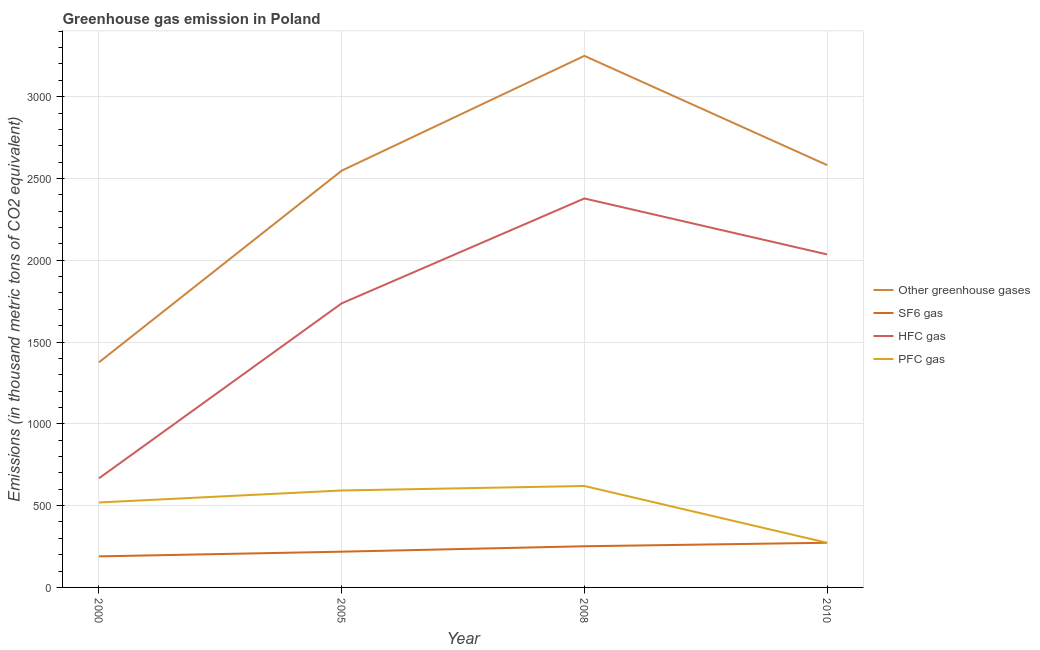Is the number of lines equal to the number of legend labels?
Make the answer very short. Yes. What is the emission of hfc gas in 2000?
Your answer should be compact. 667.2. Across all years, what is the maximum emission of pfc gas?
Provide a short and direct response. 620.1. Across all years, what is the minimum emission of greenhouse gases?
Your answer should be very brief. 1376.3. In which year was the emission of pfc gas maximum?
Offer a terse response. 2008. What is the total emission of sf6 gas in the graph?
Your answer should be compact. 933. What is the difference between the emission of hfc gas in 2005 and that in 2010?
Provide a succinct answer. -299.3. What is the difference between the emission of pfc gas in 2000 and the emission of greenhouse gases in 2008?
Make the answer very short. -2730.5. What is the average emission of sf6 gas per year?
Your response must be concise. 233.25. In the year 2005, what is the difference between the emission of pfc gas and emission of hfc gas?
Your answer should be very brief. -1144. What is the ratio of the emission of hfc gas in 2000 to that in 2008?
Your response must be concise. 0.28. Is the emission of pfc gas in 2000 less than that in 2008?
Provide a short and direct response. Yes. Is the difference between the emission of hfc gas in 2005 and 2010 greater than the difference between the emission of greenhouse gases in 2005 and 2010?
Keep it short and to the point. No. What is the difference between the highest and the second highest emission of sf6 gas?
Give a very brief answer. 21.3. What is the difference between the highest and the lowest emission of sf6 gas?
Provide a succinct answer. 83.2. In how many years, is the emission of hfc gas greater than the average emission of hfc gas taken over all years?
Make the answer very short. 3. Is it the case that in every year, the sum of the emission of sf6 gas and emission of greenhouse gases is greater than the sum of emission of hfc gas and emission of pfc gas?
Offer a terse response. No. Is it the case that in every year, the sum of the emission of greenhouse gases and emission of sf6 gas is greater than the emission of hfc gas?
Give a very brief answer. Yes. Does the emission of pfc gas monotonically increase over the years?
Your response must be concise. No. Is the emission of hfc gas strictly less than the emission of pfc gas over the years?
Give a very brief answer. No. How many lines are there?
Make the answer very short. 4. How many years are there in the graph?
Provide a short and direct response. 4. Does the graph contain any zero values?
Keep it short and to the point. No. How many legend labels are there?
Make the answer very short. 4. What is the title of the graph?
Provide a succinct answer. Greenhouse gas emission in Poland. What is the label or title of the X-axis?
Your answer should be very brief. Year. What is the label or title of the Y-axis?
Offer a very short reply. Emissions (in thousand metric tons of CO2 equivalent). What is the Emissions (in thousand metric tons of CO2 equivalent) in Other greenhouse gases in 2000?
Your answer should be very brief. 1376.3. What is the Emissions (in thousand metric tons of CO2 equivalent) of SF6 gas in 2000?
Your answer should be compact. 189.8. What is the Emissions (in thousand metric tons of CO2 equivalent) in HFC gas in 2000?
Your answer should be compact. 667.2. What is the Emissions (in thousand metric tons of CO2 equivalent) in PFC gas in 2000?
Provide a short and direct response. 519.3. What is the Emissions (in thousand metric tons of CO2 equivalent) in Other greenhouse gases in 2005?
Provide a short and direct response. 2547.9. What is the Emissions (in thousand metric tons of CO2 equivalent) of SF6 gas in 2005?
Offer a terse response. 218.5. What is the Emissions (in thousand metric tons of CO2 equivalent) of HFC gas in 2005?
Provide a succinct answer. 1736.7. What is the Emissions (in thousand metric tons of CO2 equivalent) in PFC gas in 2005?
Your answer should be very brief. 592.7. What is the Emissions (in thousand metric tons of CO2 equivalent) of Other greenhouse gases in 2008?
Provide a succinct answer. 3249.8. What is the Emissions (in thousand metric tons of CO2 equivalent) of SF6 gas in 2008?
Offer a very short reply. 251.7. What is the Emissions (in thousand metric tons of CO2 equivalent) of HFC gas in 2008?
Give a very brief answer. 2378. What is the Emissions (in thousand metric tons of CO2 equivalent) in PFC gas in 2008?
Your response must be concise. 620.1. What is the Emissions (in thousand metric tons of CO2 equivalent) in Other greenhouse gases in 2010?
Keep it short and to the point. 2582. What is the Emissions (in thousand metric tons of CO2 equivalent) of SF6 gas in 2010?
Provide a short and direct response. 273. What is the Emissions (in thousand metric tons of CO2 equivalent) of HFC gas in 2010?
Your response must be concise. 2036. What is the Emissions (in thousand metric tons of CO2 equivalent) in PFC gas in 2010?
Your answer should be very brief. 273. Across all years, what is the maximum Emissions (in thousand metric tons of CO2 equivalent) in Other greenhouse gases?
Offer a terse response. 3249.8. Across all years, what is the maximum Emissions (in thousand metric tons of CO2 equivalent) of SF6 gas?
Provide a short and direct response. 273. Across all years, what is the maximum Emissions (in thousand metric tons of CO2 equivalent) of HFC gas?
Provide a short and direct response. 2378. Across all years, what is the maximum Emissions (in thousand metric tons of CO2 equivalent) in PFC gas?
Your response must be concise. 620.1. Across all years, what is the minimum Emissions (in thousand metric tons of CO2 equivalent) of Other greenhouse gases?
Ensure brevity in your answer.  1376.3. Across all years, what is the minimum Emissions (in thousand metric tons of CO2 equivalent) of SF6 gas?
Your answer should be very brief. 189.8. Across all years, what is the minimum Emissions (in thousand metric tons of CO2 equivalent) in HFC gas?
Your answer should be very brief. 667.2. Across all years, what is the minimum Emissions (in thousand metric tons of CO2 equivalent) of PFC gas?
Offer a terse response. 273. What is the total Emissions (in thousand metric tons of CO2 equivalent) in Other greenhouse gases in the graph?
Give a very brief answer. 9756. What is the total Emissions (in thousand metric tons of CO2 equivalent) of SF6 gas in the graph?
Your answer should be very brief. 933. What is the total Emissions (in thousand metric tons of CO2 equivalent) of HFC gas in the graph?
Provide a succinct answer. 6817.9. What is the total Emissions (in thousand metric tons of CO2 equivalent) of PFC gas in the graph?
Ensure brevity in your answer.  2005.1. What is the difference between the Emissions (in thousand metric tons of CO2 equivalent) in Other greenhouse gases in 2000 and that in 2005?
Your answer should be very brief. -1171.6. What is the difference between the Emissions (in thousand metric tons of CO2 equivalent) of SF6 gas in 2000 and that in 2005?
Your answer should be very brief. -28.7. What is the difference between the Emissions (in thousand metric tons of CO2 equivalent) of HFC gas in 2000 and that in 2005?
Provide a short and direct response. -1069.5. What is the difference between the Emissions (in thousand metric tons of CO2 equivalent) of PFC gas in 2000 and that in 2005?
Your answer should be very brief. -73.4. What is the difference between the Emissions (in thousand metric tons of CO2 equivalent) of Other greenhouse gases in 2000 and that in 2008?
Make the answer very short. -1873.5. What is the difference between the Emissions (in thousand metric tons of CO2 equivalent) of SF6 gas in 2000 and that in 2008?
Provide a succinct answer. -61.9. What is the difference between the Emissions (in thousand metric tons of CO2 equivalent) in HFC gas in 2000 and that in 2008?
Your response must be concise. -1710.8. What is the difference between the Emissions (in thousand metric tons of CO2 equivalent) in PFC gas in 2000 and that in 2008?
Provide a succinct answer. -100.8. What is the difference between the Emissions (in thousand metric tons of CO2 equivalent) in Other greenhouse gases in 2000 and that in 2010?
Offer a terse response. -1205.7. What is the difference between the Emissions (in thousand metric tons of CO2 equivalent) of SF6 gas in 2000 and that in 2010?
Ensure brevity in your answer.  -83.2. What is the difference between the Emissions (in thousand metric tons of CO2 equivalent) in HFC gas in 2000 and that in 2010?
Keep it short and to the point. -1368.8. What is the difference between the Emissions (in thousand metric tons of CO2 equivalent) of PFC gas in 2000 and that in 2010?
Make the answer very short. 246.3. What is the difference between the Emissions (in thousand metric tons of CO2 equivalent) of Other greenhouse gases in 2005 and that in 2008?
Offer a terse response. -701.9. What is the difference between the Emissions (in thousand metric tons of CO2 equivalent) in SF6 gas in 2005 and that in 2008?
Provide a short and direct response. -33.2. What is the difference between the Emissions (in thousand metric tons of CO2 equivalent) in HFC gas in 2005 and that in 2008?
Give a very brief answer. -641.3. What is the difference between the Emissions (in thousand metric tons of CO2 equivalent) of PFC gas in 2005 and that in 2008?
Give a very brief answer. -27.4. What is the difference between the Emissions (in thousand metric tons of CO2 equivalent) in Other greenhouse gases in 2005 and that in 2010?
Offer a terse response. -34.1. What is the difference between the Emissions (in thousand metric tons of CO2 equivalent) of SF6 gas in 2005 and that in 2010?
Offer a very short reply. -54.5. What is the difference between the Emissions (in thousand metric tons of CO2 equivalent) of HFC gas in 2005 and that in 2010?
Keep it short and to the point. -299.3. What is the difference between the Emissions (in thousand metric tons of CO2 equivalent) of PFC gas in 2005 and that in 2010?
Ensure brevity in your answer.  319.7. What is the difference between the Emissions (in thousand metric tons of CO2 equivalent) of Other greenhouse gases in 2008 and that in 2010?
Provide a short and direct response. 667.8. What is the difference between the Emissions (in thousand metric tons of CO2 equivalent) in SF6 gas in 2008 and that in 2010?
Your answer should be compact. -21.3. What is the difference between the Emissions (in thousand metric tons of CO2 equivalent) of HFC gas in 2008 and that in 2010?
Provide a short and direct response. 342. What is the difference between the Emissions (in thousand metric tons of CO2 equivalent) in PFC gas in 2008 and that in 2010?
Offer a terse response. 347.1. What is the difference between the Emissions (in thousand metric tons of CO2 equivalent) in Other greenhouse gases in 2000 and the Emissions (in thousand metric tons of CO2 equivalent) in SF6 gas in 2005?
Keep it short and to the point. 1157.8. What is the difference between the Emissions (in thousand metric tons of CO2 equivalent) of Other greenhouse gases in 2000 and the Emissions (in thousand metric tons of CO2 equivalent) of HFC gas in 2005?
Provide a succinct answer. -360.4. What is the difference between the Emissions (in thousand metric tons of CO2 equivalent) of Other greenhouse gases in 2000 and the Emissions (in thousand metric tons of CO2 equivalent) of PFC gas in 2005?
Offer a very short reply. 783.6. What is the difference between the Emissions (in thousand metric tons of CO2 equivalent) in SF6 gas in 2000 and the Emissions (in thousand metric tons of CO2 equivalent) in HFC gas in 2005?
Your answer should be very brief. -1546.9. What is the difference between the Emissions (in thousand metric tons of CO2 equivalent) in SF6 gas in 2000 and the Emissions (in thousand metric tons of CO2 equivalent) in PFC gas in 2005?
Ensure brevity in your answer.  -402.9. What is the difference between the Emissions (in thousand metric tons of CO2 equivalent) of HFC gas in 2000 and the Emissions (in thousand metric tons of CO2 equivalent) of PFC gas in 2005?
Ensure brevity in your answer.  74.5. What is the difference between the Emissions (in thousand metric tons of CO2 equivalent) in Other greenhouse gases in 2000 and the Emissions (in thousand metric tons of CO2 equivalent) in SF6 gas in 2008?
Offer a very short reply. 1124.6. What is the difference between the Emissions (in thousand metric tons of CO2 equivalent) of Other greenhouse gases in 2000 and the Emissions (in thousand metric tons of CO2 equivalent) of HFC gas in 2008?
Keep it short and to the point. -1001.7. What is the difference between the Emissions (in thousand metric tons of CO2 equivalent) in Other greenhouse gases in 2000 and the Emissions (in thousand metric tons of CO2 equivalent) in PFC gas in 2008?
Offer a very short reply. 756.2. What is the difference between the Emissions (in thousand metric tons of CO2 equivalent) in SF6 gas in 2000 and the Emissions (in thousand metric tons of CO2 equivalent) in HFC gas in 2008?
Provide a succinct answer. -2188.2. What is the difference between the Emissions (in thousand metric tons of CO2 equivalent) in SF6 gas in 2000 and the Emissions (in thousand metric tons of CO2 equivalent) in PFC gas in 2008?
Your response must be concise. -430.3. What is the difference between the Emissions (in thousand metric tons of CO2 equivalent) in HFC gas in 2000 and the Emissions (in thousand metric tons of CO2 equivalent) in PFC gas in 2008?
Provide a succinct answer. 47.1. What is the difference between the Emissions (in thousand metric tons of CO2 equivalent) of Other greenhouse gases in 2000 and the Emissions (in thousand metric tons of CO2 equivalent) of SF6 gas in 2010?
Offer a terse response. 1103.3. What is the difference between the Emissions (in thousand metric tons of CO2 equivalent) in Other greenhouse gases in 2000 and the Emissions (in thousand metric tons of CO2 equivalent) in HFC gas in 2010?
Offer a terse response. -659.7. What is the difference between the Emissions (in thousand metric tons of CO2 equivalent) in Other greenhouse gases in 2000 and the Emissions (in thousand metric tons of CO2 equivalent) in PFC gas in 2010?
Provide a succinct answer. 1103.3. What is the difference between the Emissions (in thousand metric tons of CO2 equivalent) in SF6 gas in 2000 and the Emissions (in thousand metric tons of CO2 equivalent) in HFC gas in 2010?
Ensure brevity in your answer.  -1846.2. What is the difference between the Emissions (in thousand metric tons of CO2 equivalent) of SF6 gas in 2000 and the Emissions (in thousand metric tons of CO2 equivalent) of PFC gas in 2010?
Offer a very short reply. -83.2. What is the difference between the Emissions (in thousand metric tons of CO2 equivalent) in HFC gas in 2000 and the Emissions (in thousand metric tons of CO2 equivalent) in PFC gas in 2010?
Make the answer very short. 394.2. What is the difference between the Emissions (in thousand metric tons of CO2 equivalent) in Other greenhouse gases in 2005 and the Emissions (in thousand metric tons of CO2 equivalent) in SF6 gas in 2008?
Your response must be concise. 2296.2. What is the difference between the Emissions (in thousand metric tons of CO2 equivalent) of Other greenhouse gases in 2005 and the Emissions (in thousand metric tons of CO2 equivalent) of HFC gas in 2008?
Ensure brevity in your answer.  169.9. What is the difference between the Emissions (in thousand metric tons of CO2 equivalent) of Other greenhouse gases in 2005 and the Emissions (in thousand metric tons of CO2 equivalent) of PFC gas in 2008?
Give a very brief answer. 1927.8. What is the difference between the Emissions (in thousand metric tons of CO2 equivalent) in SF6 gas in 2005 and the Emissions (in thousand metric tons of CO2 equivalent) in HFC gas in 2008?
Ensure brevity in your answer.  -2159.5. What is the difference between the Emissions (in thousand metric tons of CO2 equivalent) of SF6 gas in 2005 and the Emissions (in thousand metric tons of CO2 equivalent) of PFC gas in 2008?
Your answer should be compact. -401.6. What is the difference between the Emissions (in thousand metric tons of CO2 equivalent) of HFC gas in 2005 and the Emissions (in thousand metric tons of CO2 equivalent) of PFC gas in 2008?
Your answer should be compact. 1116.6. What is the difference between the Emissions (in thousand metric tons of CO2 equivalent) in Other greenhouse gases in 2005 and the Emissions (in thousand metric tons of CO2 equivalent) in SF6 gas in 2010?
Provide a succinct answer. 2274.9. What is the difference between the Emissions (in thousand metric tons of CO2 equivalent) of Other greenhouse gases in 2005 and the Emissions (in thousand metric tons of CO2 equivalent) of HFC gas in 2010?
Provide a short and direct response. 511.9. What is the difference between the Emissions (in thousand metric tons of CO2 equivalent) in Other greenhouse gases in 2005 and the Emissions (in thousand metric tons of CO2 equivalent) in PFC gas in 2010?
Give a very brief answer. 2274.9. What is the difference between the Emissions (in thousand metric tons of CO2 equivalent) of SF6 gas in 2005 and the Emissions (in thousand metric tons of CO2 equivalent) of HFC gas in 2010?
Provide a succinct answer. -1817.5. What is the difference between the Emissions (in thousand metric tons of CO2 equivalent) in SF6 gas in 2005 and the Emissions (in thousand metric tons of CO2 equivalent) in PFC gas in 2010?
Give a very brief answer. -54.5. What is the difference between the Emissions (in thousand metric tons of CO2 equivalent) in HFC gas in 2005 and the Emissions (in thousand metric tons of CO2 equivalent) in PFC gas in 2010?
Provide a short and direct response. 1463.7. What is the difference between the Emissions (in thousand metric tons of CO2 equivalent) of Other greenhouse gases in 2008 and the Emissions (in thousand metric tons of CO2 equivalent) of SF6 gas in 2010?
Your answer should be compact. 2976.8. What is the difference between the Emissions (in thousand metric tons of CO2 equivalent) of Other greenhouse gases in 2008 and the Emissions (in thousand metric tons of CO2 equivalent) of HFC gas in 2010?
Provide a succinct answer. 1213.8. What is the difference between the Emissions (in thousand metric tons of CO2 equivalent) of Other greenhouse gases in 2008 and the Emissions (in thousand metric tons of CO2 equivalent) of PFC gas in 2010?
Your answer should be very brief. 2976.8. What is the difference between the Emissions (in thousand metric tons of CO2 equivalent) of SF6 gas in 2008 and the Emissions (in thousand metric tons of CO2 equivalent) of HFC gas in 2010?
Offer a terse response. -1784.3. What is the difference between the Emissions (in thousand metric tons of CO2 equivalent) of SF6 gas in 2008 and the Emissions (in thousand metric tons of CO2 equivalent) of PFC gas in 2010?
Your response must be concise. -21.3. What is the difference between the Emissions (in thousand metric tons of CO2 equivalent) of HFC gas in 2008 and the Emissions (in thousand metric tons of CO2 equivalent) of PFC gas in 2010?
Keep it short and to the point. 2105. What is the average Emissions (in thousand metric tons of CO2 equivalent) of Other greenhouse gases per year?
Your answer should be compact. 2439. What is the average Emissions (in thousand metric tons of CO2 equivalent) of SF6 gas per year?
Offer a very short reply. 233.25. What is the average Emissions (in thousand metric tons of CO2 equivalent) in HFC gas per year?
Provide a short and direct response. 1704.47. What is the average Emissions (in thousand metric tons of CO2 equivalent) of PFC gas per year?
Offer a very short reply. 501.27. In the year 2000, what is the difference between the Emissions (in thousand metric tons of CO2 equivalent) in Other greenhouse gases and Emissions (in thousand metric tons of CO2 equivalent) in SF6 gas?
Give a very brief answer. 1186.5. In the year 2000, what is the difference between the Emissions (in thousand metric tons of CO2 equivalent) in Other greenhouse gases and Emissions (in thousand metric tons of CO2 equivalent) in HFC gas?
Offer a very short reply. 709.1. In the year 2000, what is the difference between the Emissions (in thousand metric tons of CO2 equivalent) in Other greenhouse gases and Emissions (in thousand metric tons of CO2 equivalent) in PFC gas?
Your answer should be very brief. 857. In the year 2000, what is the difference between the Emissions (in thousand metric tons of CO2 equivalent) of SF6 gas and Emissions (in thousand metric tons of CO2 equivalent) of HFC gas?
Keep it short and to the point. -477.4. In the year 2000, what is the difference between the Emissions (in thousand metric tons of CO2 equivalent) in SF6 gas and Emissions (in thousand metric tons of CO2 equivalent) in PFC gas?
Give a very brief answer. -329.5. In the year 2000, what is the difference between the Emissions (in thousand metric tons of CO2 equivalent) in HFC gas and Emissions (in thousand metric tons of CO2 equivalent) in PFC gas?
Offer a terse response. 147.9. In the year 2005, what is the difference between the Emissions (in thousand metric tons of CO2 equivalent) of Other greenhouse gases and Emissions (in thousand metric tons of CO2 equivalent) of SF6 gas?
Your answer should be very brief. 2329.4. In the year 2005, what is the difference between the Emissions (in thousand metric tons of CO2 equivalent) in Other greenhouse gases and Emissions (in thousand metric tons of CO2 equivalent) in HFC gas?
Offer a very short reply. 811.2. In the year 2005, what is the difference between the Emissions (in thousand metric tons of CO2 equivalent) in Other greenhouse gases and Emissions (in thousand metric tons of CO2 equivalent) in PFC gas?
Give a very brief answer. 1955.2. In the year 2005, what is the difference between the Emissions (in thousand metric tons of CO2 equivalent) of SF6 gas and Emissions (in thousand metric tons of CO2 equivalent) of HFC gas?
Keep it short and to the point. -1518.2. In the year 2005, what is the difference between the Emissions (in thousand metric tons of CO2 equivalent) in SF6 gas and Emissions (in thousand metric tons of CO2 equivalent) in PFC gas?
Your answer should be very brief. -374.2. In the year 2005, what is the difference between the Emissions (in thousand metric tons of CO2 equivalent) of HFC gas and Emissions (in thousand metric tons of CO2 equivalent) of PFC gas?
Your answer should be very brief. 1144. In the year 2008, what is the difference between the Emissions (in thousand metric tons of CO2 equivalent) in Other greenhouse gases and Emissions (in thousand metric tons of CO2 equivalent) in SF6 gas?
Your response must be concise. 2998.1. In the year 2008, what is the difference between the Emissions (in thousand metric tons of CO2 equivalent) in Other greenhouse gases and Emissions (in thousand metric tons of CO2 equivalent) in HFC gas?
Offer a very short reply. 871.8. In the year 2008, what is the difference between the Emissions (in thousand metric tons of CO2 equivalent) of Other greenhouse gases and Emissions (in thousand metric tons of CO2 equivalent) of PFC gas?
Your response must be concise. 2629.7. In the year 2008, what is the difference between the Emissions (in thousand metric tons of CO2 equivalent) in SF6 gas and Emissions (in thousand metric tons of CO2 equivalent) in HFC gas?
Your response must be concise. -2126.3. In the year 2008, what is the difference between the Emissions (in thousand metric tons of CO2 equivalent) in SF6 gas and Emissions (in thousand metric tons of CO2 equivalent) in PFC gas?
Keep it short and to the point. -368.4. In the year 2008, what is the difference between the Emissions (in thousand metric tons of CO2 equivalent) in HFC gas and Emissions (in thousand metric tons of CO2 equivalent) in PFC gas?
Give a very brief answer. 1757.9. In the year 2010, what is the difference between the Emissions (in thousand metric tons of CO2 equivalent) in Other greenhouse gases and Emissions (in thousand metric tons of CO2 equivalent) in SF6 gas?
Give a very brief answer. 2309. In the year 2010, what is the difference between the Emissions (in thousand metric tons of CO2 equivalent) in Other greenhouse gases and Emissions (in thousand metric tons of CO2 equivalent) in HFC gas?
Make the answer very short. 546. In the year 2010, what is the difference between the Emissions (in thousand metric tons of CO2 equivalent) of Other greenhouse gases and Emissions (in thousand metric tons of CO2 equivalent) of PFC gas?
Your answer should be compact. 2309. In the year 2010, what is the difference between the Emissions (in thousand metric tons of CO2 equivalent) in SF6 gas and Emissions (in thousand metric tons of CO2 equivalent) in HFC gas?
Make the answer very short. -1763. In the year 2010, what is the difference between the Emissions (in thousand metric tons of CO2 equivalent) of SF6 gas and Emissions (in thousand metric tons of CO2 equivalent) of PFC gas?
Your response must be concise. 0. In the year 2010, what is the difference between the Emissions (in thousand metric tons of CO2 equivalent) in HFC gas and Emissions (in thousand metric tons of CO2 equivalent) in PFC gas?
Offer a very short reply. 1763. What is the ratio of the Emissions (in thousand metric tons of CO2 equivalent) of Other greenhouse gases in 2000 to that in 2005?
Provide a succinct answer. 0.54. What is the ratio of the Emissions (in thousand metric tons of CO2 equivalent) in SF6 gas in 2000 to that in 2005?
Give a very brief answer. 0.87. What is the ratio of the Emissions (in thousand metric tons of CO2 equivalent) in HFC gas in 2000 to that in 2005?
Offer a very short reply. 0.38. What is the ratio of the Emissions (in thousand metric tons of CO2 equivalent) of PFC gas in 2000 to that in 2005?
Offer a very short reply. 0.88. What is the ratio of the Emissions (in thousand metric tons of CO2 equivalent) in Other greenhouse gases in 2000 to that in 2008?
Make the answer very short. 0.42. What is the ratio of the Emissions (in thousand metric tons of CO2 equivalent) of SF6 gas in 2000 to that in 2008?
Offer a very short reply. 0.75. What is the ratio of the Emissions (in thousand metric tons of CO2 equivalent) in HFC gas in 2000 to that in 2008?
Keep it short and to the point. 0.28. What is the ratio of the Emissions (in thousand metric tons of CO2 equivalent) in PFC gas in 2000 to that in 2008?
Provide a succinct answer. 0.84. What is the ratio of the Emissions (in thousand metric tons of CO2 equivalent) of Other greenhouse gases in 2000 to that in 2010?
Give a very brief answer. 0.53. What is the ratio of the Emissions (in thousand metric tons of CO2 equivalent) in SF6 gas in 2000 to that in 2010?
Make the answer very short. 0.7. What is the ratio of the Emissions (in thousand metric tons of CO2 equivalent) in HFC gas in 2000 to that in 2010?
Ensure brevity in your answer.  0.33. What is the ratio of the Emissions (in thousand metric tons of CO2 equivalent) of PFC gas in 2000 to that in 2010?
Your answer should be compact. 1.9. What is the ratio of the Emissions (in thousand metric tons of CO2 equivalent) of Other greenhouse gases in 2005 to that in 2008?
Your answer should be very brief. 0.78. What is the ratio of the Emissions (in thousand metric tons of CO2 equivalent) in SF6 gas in 2005 to that in 2008?
Provide a succinct answer. 0.87. What is the ratio of the Emissions (in thousand metric tons of CO2 equivalent) of HFC gas in 2005 to that in 2008?
Ensure brevity in your answer.  0.73. What is the ratio of the Emissions (in thousand metric tons of CO2 equivalent) of PFC gas in 2005 to that in 2008?
Your answer should be compact. 0.96. What is the ratio of the Emissions (in thousand metric tons of CO2 equivalent) in Other greenhouse gases in 2005 to that in 2010?
Provide a short and direct response. 0.99. What is the ratio of the Emissions (in thousand metric tons of CO2 equivalent) in SF6 gas in 2005 to that in 2010?
Make the answer very short. 0.8. What is the ratio of the Emissions (in thousand metric tons of CO2 equivalent) of HFC gas in 2005 to that in 2010?
Keep it short and to the point. 0.85. What is the ratio of the Emissions (in thousand metric tons of CO2 equivalent) in PFC gas in 2005 to that in 2010?
Your response must be concise. 2.17. What is the ratio of the Emissions (in thousand metric tons of CO2 equivalent) in Other greenhouse gases in 2008 to that in 2010?
Keep it short and to the point. 1.26. What is the ratio of the Emissions (in thousand metric tons of CO2 equivalent) of SF6 gas in 2008 to that in 2010?
Ensure brevity in your answer.  0.92. What is the ratio of the Emissions (in thousand metric tons of CO2 equivalent) in HFC gas in 2008 to that in 2010?
Offer a terse response. 1.17. What is the ratio of the Emissions (in thousand metric tons of CO2 equivalent) of PFC gas in 2008 to that in 2010?
Ensure brevity in your answer.  2.27. What is the difference between the highest and the second highest Emissions (in thousand metric tons of CO2 equivalent) of Other greenhouse gases?
Your answer should be very brief. 667.8. What is the difference between the highest and the second highest Emissions (in thousand metric tons of CO2 equivalent) of SF6 gas?
Provide a succinct answer. 21.3. What is the difference between the highest and the second highest Emissions (in thousand metric tons of CO2 equivalent) of HFC gas?
Your answer should be very brief. 342. What is the difference between the highest and the second highest Emissions (in thousand metric tons of CO2 equivalent) of PFC gas?
Make the answer very short. 27.4. What is the difference between the highest and the lowest Emissions (in thousand metric tons of CO2 equivalent) in Other greenhouse gases?
Offer a terse response. 1873.5. What is the difference between the highest and the lowest Emissions (in thousand metric tons of CO2 equivalent) in SF6 gas?
Offer a terse response. 83.2. What is the difference between the highest and the lowest Emissions (in thousand metric tons of CO2 equivalent) in HFC gas?
Provide a short and direct response. 1710.8. What is the difference between the highest and the lowest Emissions (in thousand metric tons of CO2 equivalent) in PFC gas?
Offer a very short reply. 347.1. 